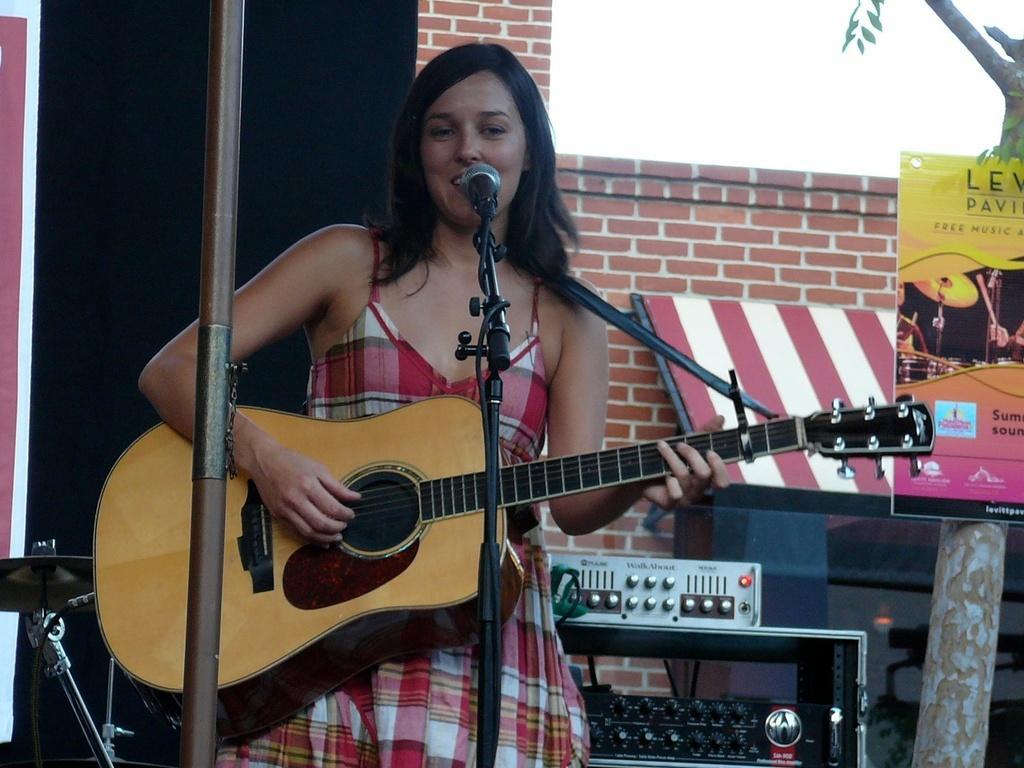Could you give a brief overview of what you see in this image? In this image the woman is standing and holding a guitar. There is a mic and a stand. 